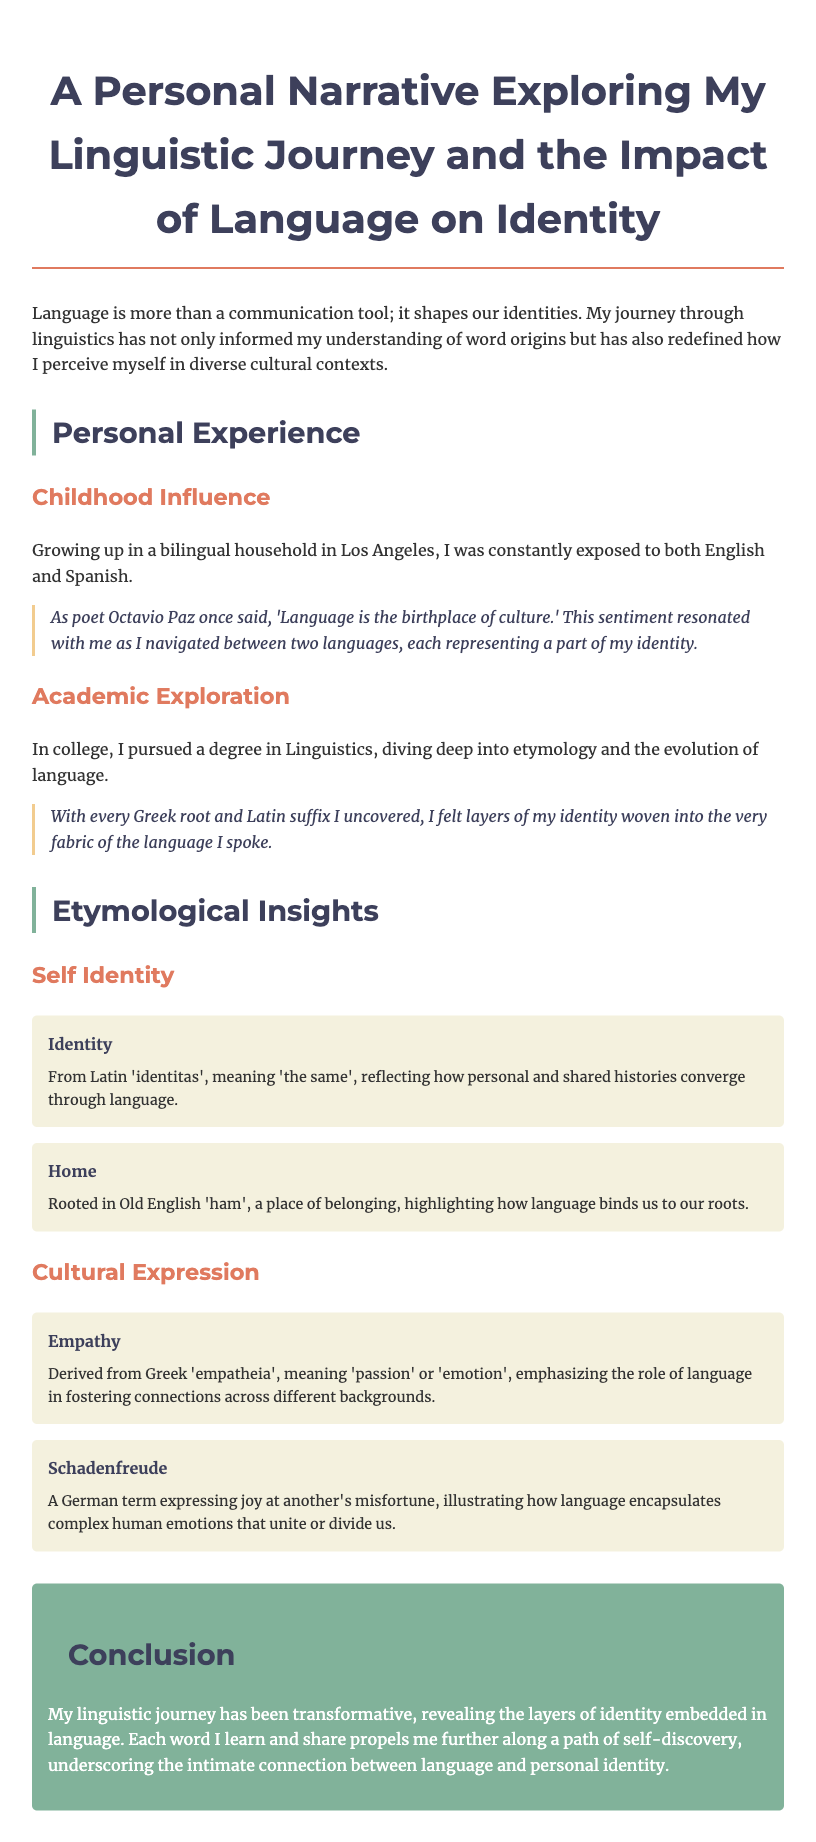What is the main topic of the document? The main topic of the document is the author's personal experiences and reflections on their linguistic journey and the impact of language on identity.
Answer: A personal narrative exploring my linguistic journey and the impact of language on identity Who said, "Language is the birthplace of culture"? This quote is attributed to poet Octavio Paz, who reflects on the deep relationship between language and culture in the author's narrative.
Answer: Octavio Paz What degree did the author pursue in college? The author pursued a degree in Linguistics, focusing on etymology and language evolution during their academic exploration.
Answer: Linguistics What is the etymological meaning of 'identity'? The term 'identity' originates from the Latin word 'identitas', which signifies 'the same', indicating a connection between personal histories and language.
Answer: The same Which German term is mentioned to describe joy at another's misfortune? The document refers to the term 'Schadenfreude' to illustrate complex emotions in language that can both unite and divide us.
Answer: Schadenfreude What language did the author grow up speaking besides English? The author grew up in a bilingual environment where they were continually exposed to both English and Spanish languages.
Answer: Spanish What does the Old English word 'ham' signify? The term 'ham', from Old English, signifies a place of belonging, reinforcing the concept of roots connected through language.
Answer: A place of belonging In which city did the author grow up? The author mentions growing up in Los Angeles, emphasizing the multicultural background influencing their linguistic journey.
Answer: Los Angeles 